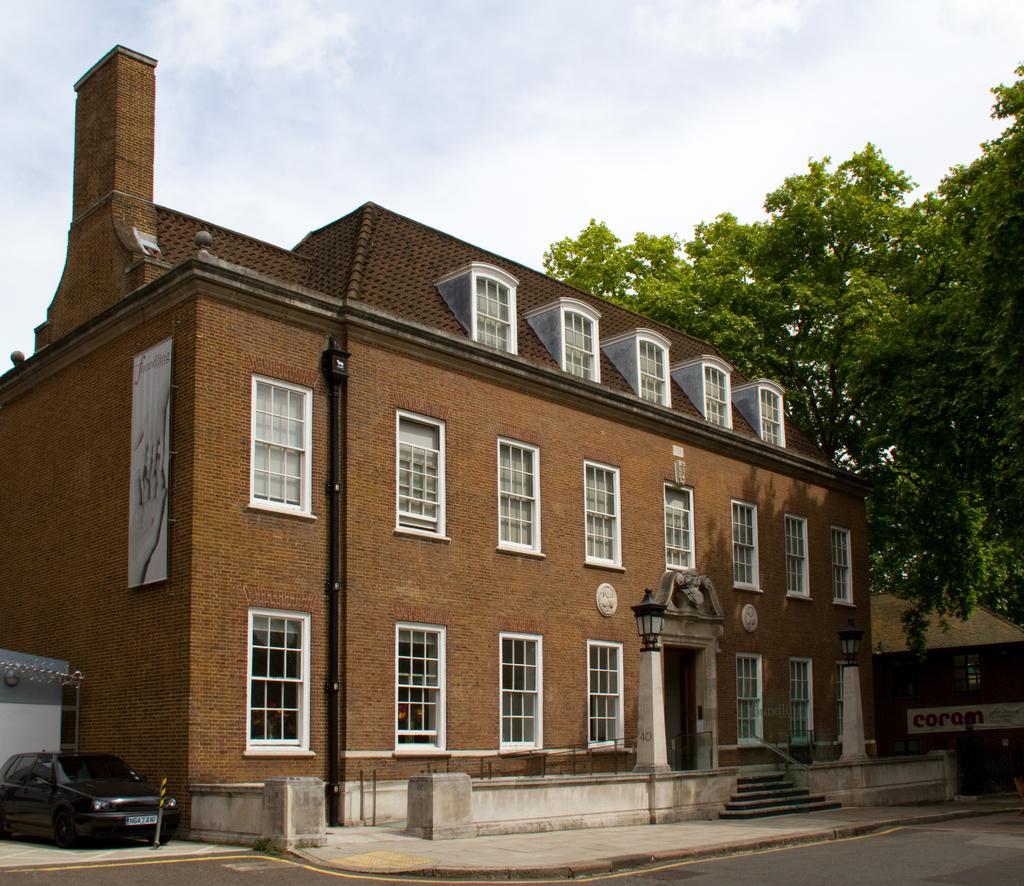Could you give a brief overview of what you see in this image? In this there is a brown color house with white windows. In the front side of the image there are some step and black color lamppost. Behind there are some trees and above a blue clear sky. 